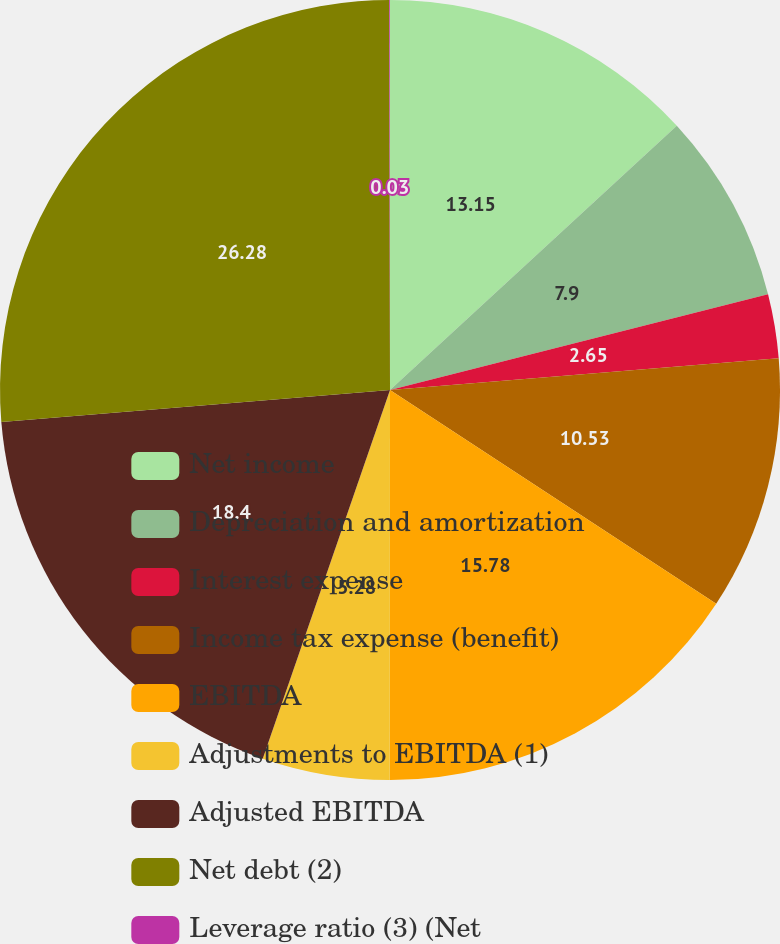Convert chart to OTSL. <chart><loc_0><loc_0><loc_500><loc_500><pie_chart><fcel>Net income<fcel>Depreciation and amortization<fcel>Interest expense<fcel>Income tax expense (benefit)<fcel>EBITDA<fcel>Adjustments to EBITDA (1)<fcel>Adjusted EBITDA<fcel>Net debt (2)<fcel>Leverage ratio (3) (Net<nl><fcel>13.15%<fcel>7.9%<fcel>2.65%<fcel>10.53%<fcel>15.78%<fcel>5.28%<fcel>18.4%<fcel>26.28%<fcel>0.03%<nl></chart> 